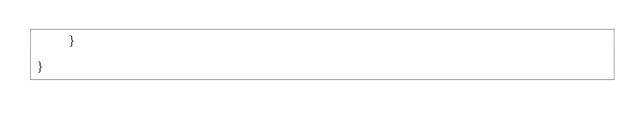<code> <loc_0><loc_0><loc_500><loc_500><_Java_>    }
    
}
</code> 